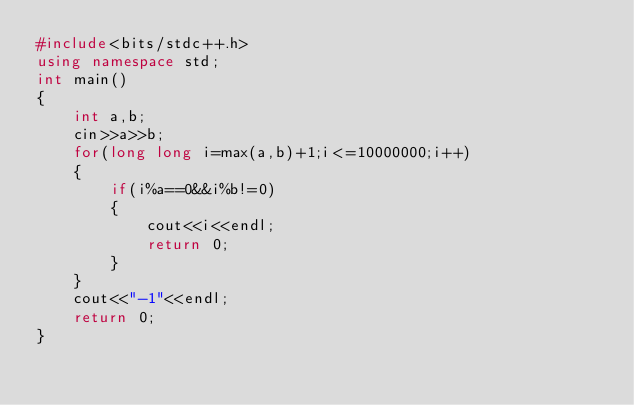<code> <loc_0><loc_0><loc_500><loc_500><_C++_>#include<bits/stdc++.h>
using namespace std;
int main()
{
    int a,b;
    cin>>a>>b;
    for(long long i=max(a,b)+1;i<=10000000;i++)
    {
        if(i%a==0&&i%b!=0)
        {
            cout<<i<<endl;
            return 0;
        }
    }
    cout<<"-1"<<endl;
    return 0;
}</code> 